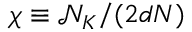Convert formula to latex. <formula><loc_0><loc_0><loc_500><loc_500>\chi \equiv \mathcal { N } _ { K } / ( 2 d N )</formula> 